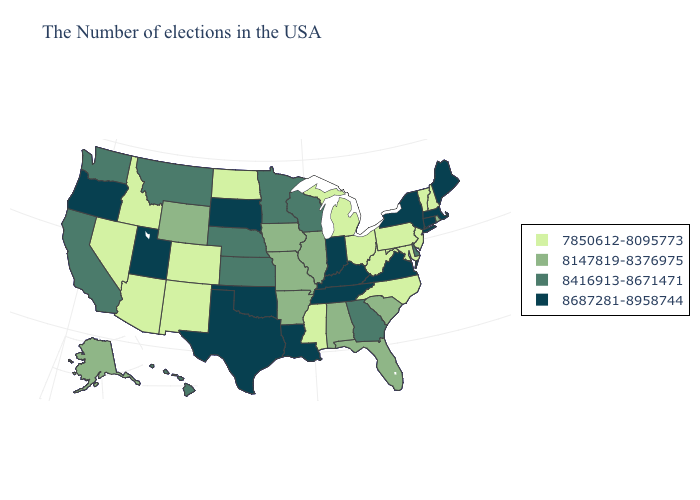Among the states that border North Carolina , which have the highest value?
Concise answer only. Virginia, Tennessee. Name the states that have a value in the range 8687281-8958744?
Keep it brief. Maine, Massachusetts, Connecticut, New York, Virginia, Kentucky, Indiana, Tennessee, Louisiana, Oklahoma, Texas, South Dakota, Utah, Oregon. Does Wyoming have the lowest value in the USA?
Concise answer only. No. What is the highest value in the South ?
Keep it brief. 8687281-8958744. Among the states that border Ohio , does Indiana have the lowest value?
Concise answer only. No. Among the states that border Connecticut , does Massachusetts have the lowest value?
Write a very short answer. No. Does Georgia have the same value as South Dakota?
Give a very brief answer. No. Which states have the lowest value in the South?
Concise answer only. Maryland, North Carolina, West Virginia, Mississippi. What is the value of Minnesota?
Be succinct. 8416913-8671471. Name the states that have a value in the range 8687281-8958744?
Give a very brief answer. Maine, Massachusetts, Connecticut, New York, Virginia, Kentucky, Indiana, Tennessee, Louisiana, Oklahoma, Texas, South Dakota, Utah, Oregon. What is the value of New Mexico?
Write a very short answer. 7850612-8095773. Name the states that have a value in the range 8416913-8671471?
Quick response, please. Delaware, Georgia, Wisconsin, Minnesota, Kansas, Nebraska, Montana, California, Washington, Hawaii. Which states have the highest value in the USA?
Short answer required. Maine, Massachusetts, Connecticut, New York, Virginia, Kentucky, Indiana, Tennessee, Louisiana, Oklahoma, Texas, South Dakota, Utah, Oregon. What is the value of Iowa?
Be succinct. 8147819-8376975. What is the value of Arkansas?
Keep it brief. 8147819-8376975. 